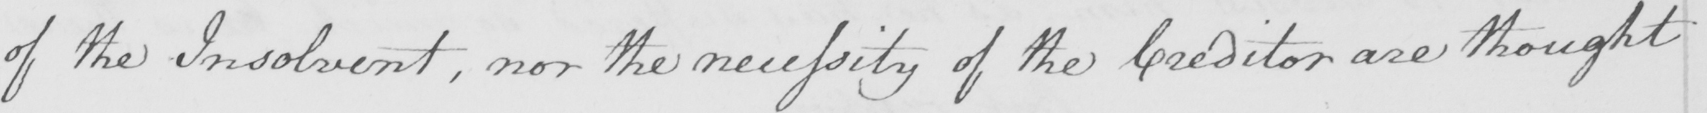Please transcribe the handwritten text in this image. of the Insolvent , nor the necessity of the Creditor are thought 